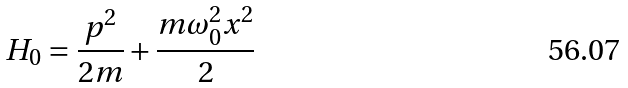<formula> <loc_0><loc_0><loc_500><loc_500>H _ { 0 } = { \frac { p ^ { 2 } } { 2 m } } + { \frac { m \omega _ { 0 } ^ { 2 } x ^ { 2 } } { 2 } }</formula> 